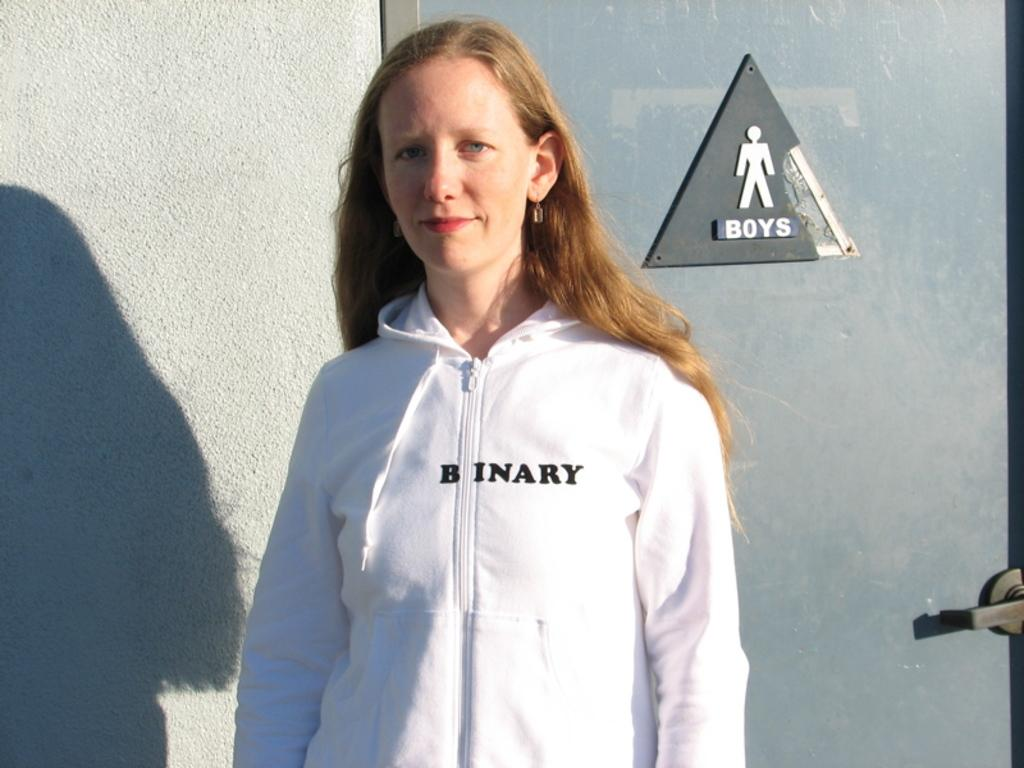<image>
Present a compact description of the photo's key features. A woman in a "binary" sweatshirt stands in front of a boys bathroom. 